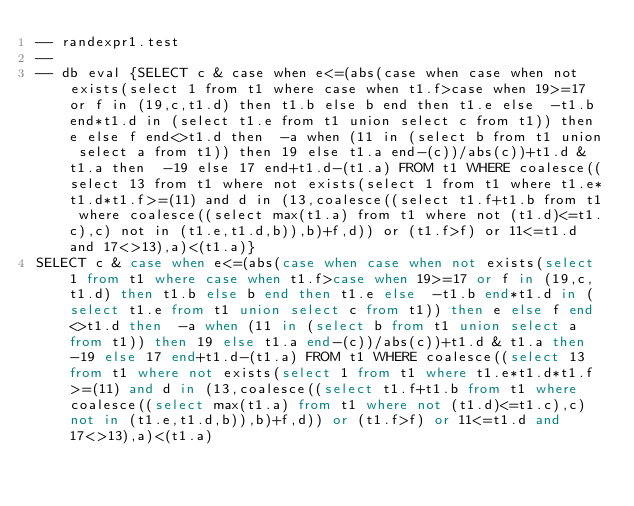<code> <loc_0><loc_0><loc_500><loc_500><_SQL_>-- randexpr1.test
-- 
-- db eval {SELECT c & case when e<=(abs(case when case when not exists(select 1 from t1 where case when t1.f>case when 19>=17 or f in (19,c,t1.d) then t1.b else b end then t1.e else  -t1.b end*t1.d in (select t1.e from t1 union select c from t1)) then e else f end<>t1.d then  -a when (11 in (select b from t1 union select a from t1)) then 19 else t1.a end-(c))/abs(c))+t1.d & t1.a then  -19 else 17 end+t1.d-(t1.a) FROM t1 WHERE coalesce((select 13 from t1 where not exists(select 1 from t1 where t1.e*t1.d*t1.f>=(11) and d in (13,coalesce((select t1.f+t1.b from t1 where coalesce((select max(t1.a) from t1 where not (t1.d)<=t1.c),c) not in (t1.e,t1.d,b)),b)+f,d)) or (t1.f>f) or 11<=t1.d and 17<>13),a)<(t1.a)}
SELECT c & case when e<=(abs(case when case when not exists(select 1 from t1 where case when t1.f>case when 19>=17 or f in (19,c,t1.d) then t1.b else b end then t1.e else  -t1.b end*t1.d in (select t1.e from t1 union select c from t1)) then e else f end<>t1.d then  -a when (11 in (select b from t1 union select a from t1)) then 19 else t1.a end-(c))/abs(c))+t1.d & t1.a then  -19 else 17 end+t1.d-(t1.a) FROM t1 WHERE coalesce((select 13 from t1 where not exists(select 1 from t1 where t1.e*t1.d*t1.f>=(11) and d in (13,coalesce((select t1.f+t1.b from t1 where coalesce((select max(t1.a) from t1 where not (t1.d)<=t1.c),c) not in (t1.e,t1.d,b)),b)+f,d)) or (t1.f>f) or 11<=t1.d and 17<>13),a)<(t1.a)</code> 